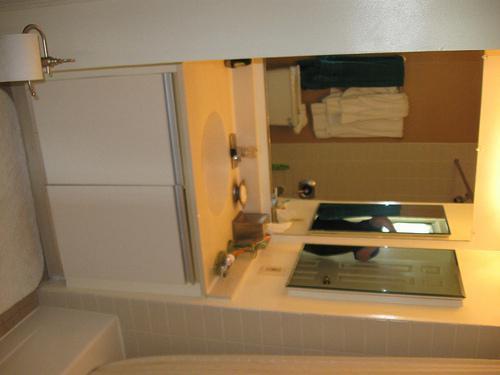How many lamps are there?
Give a very brief answer. 1. 